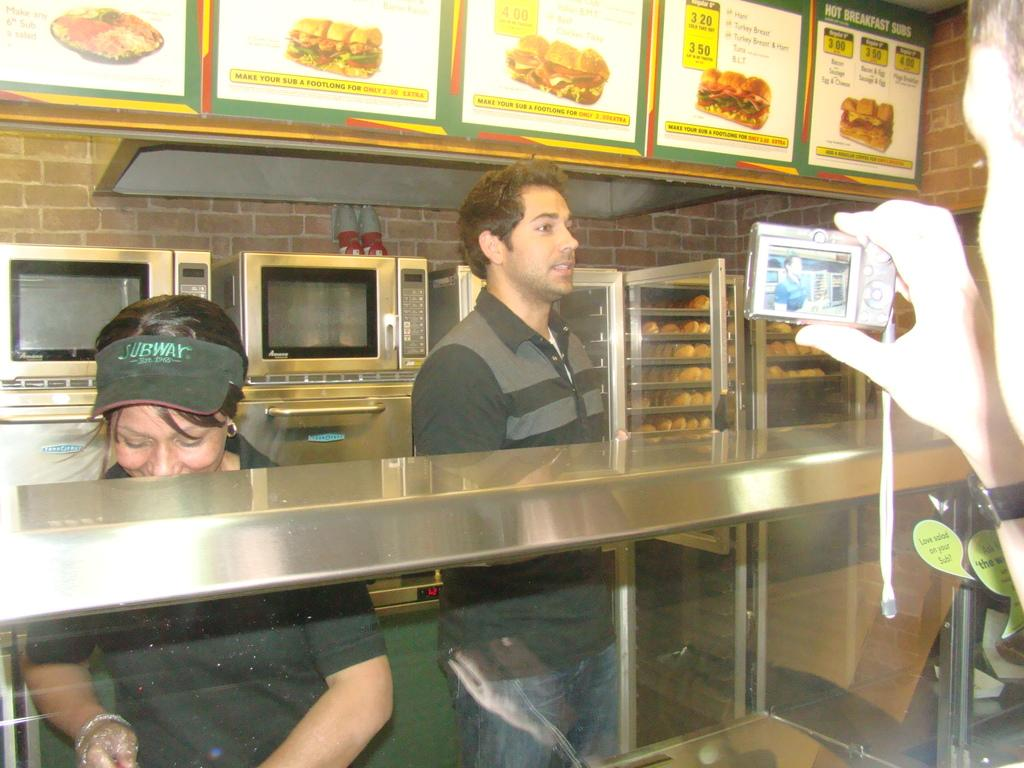<image>
Render a clear and concise summary of the photo. Subway workers stand behind a counter as their photo is taken. 